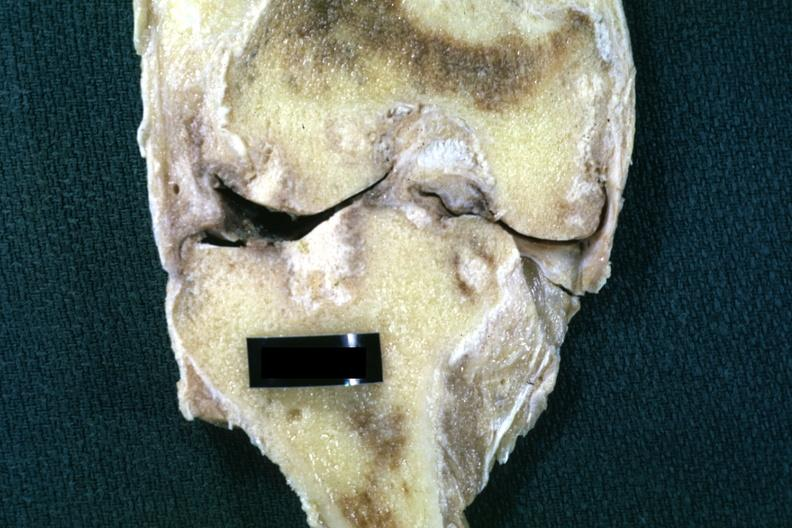does this image show fixed tissue frontal section of joint with obvious cartilage loss and subsynovial fibrosis and synovial fibrosis?
Answer the question using a single word or phrase. Yes 